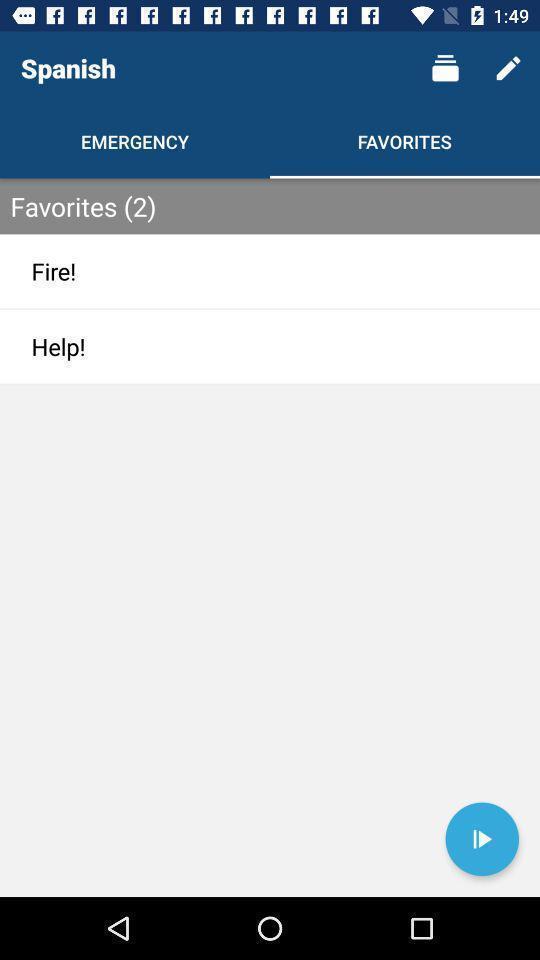Provide a textual representation of this image. Page showing about different categories in application. 